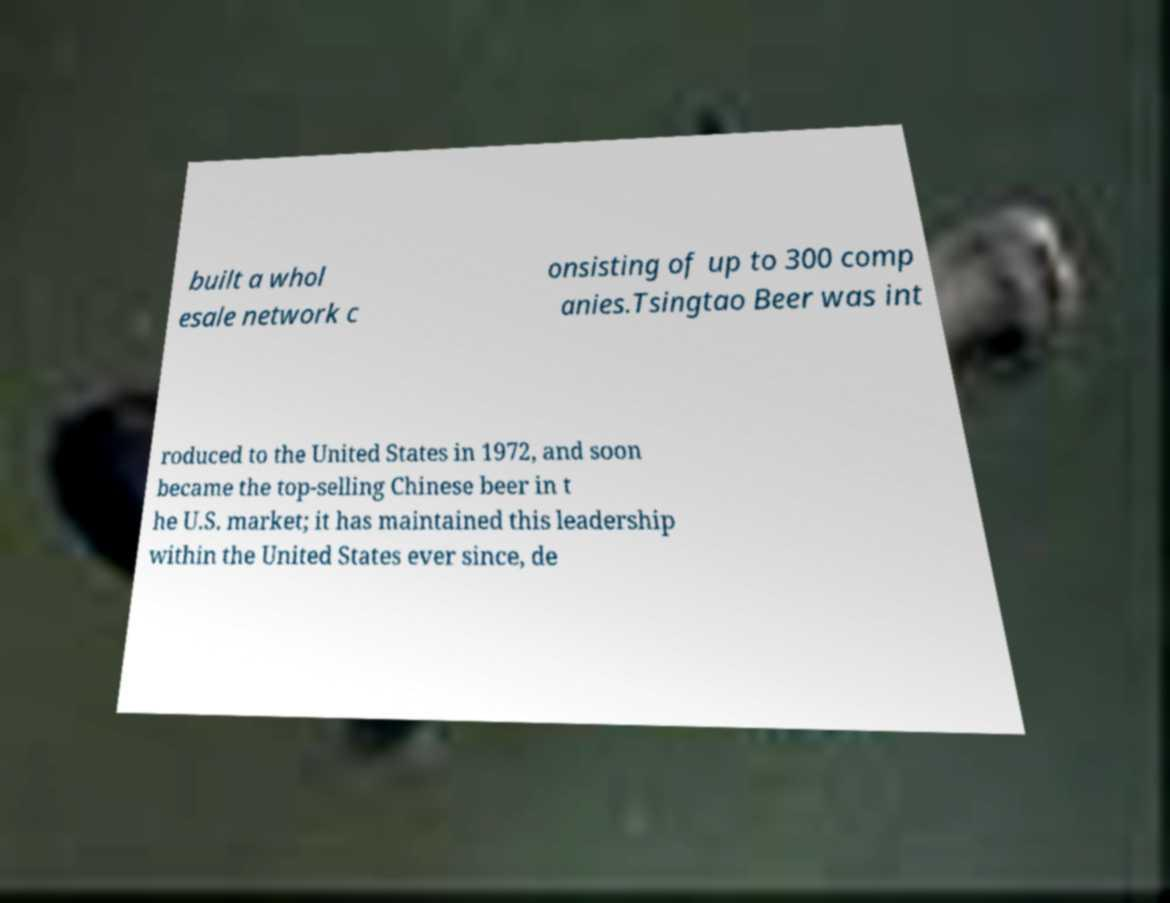Please identify and transcribe the text found in this image. built a whol esale network c onsisting of up to 300 comp anies.Tsingtao Beer was int roduced to the United States in 1972, and soon became the top-selling Chinese beer in t he U.S. market; it has maintained this leadership within the United States ever since, de 